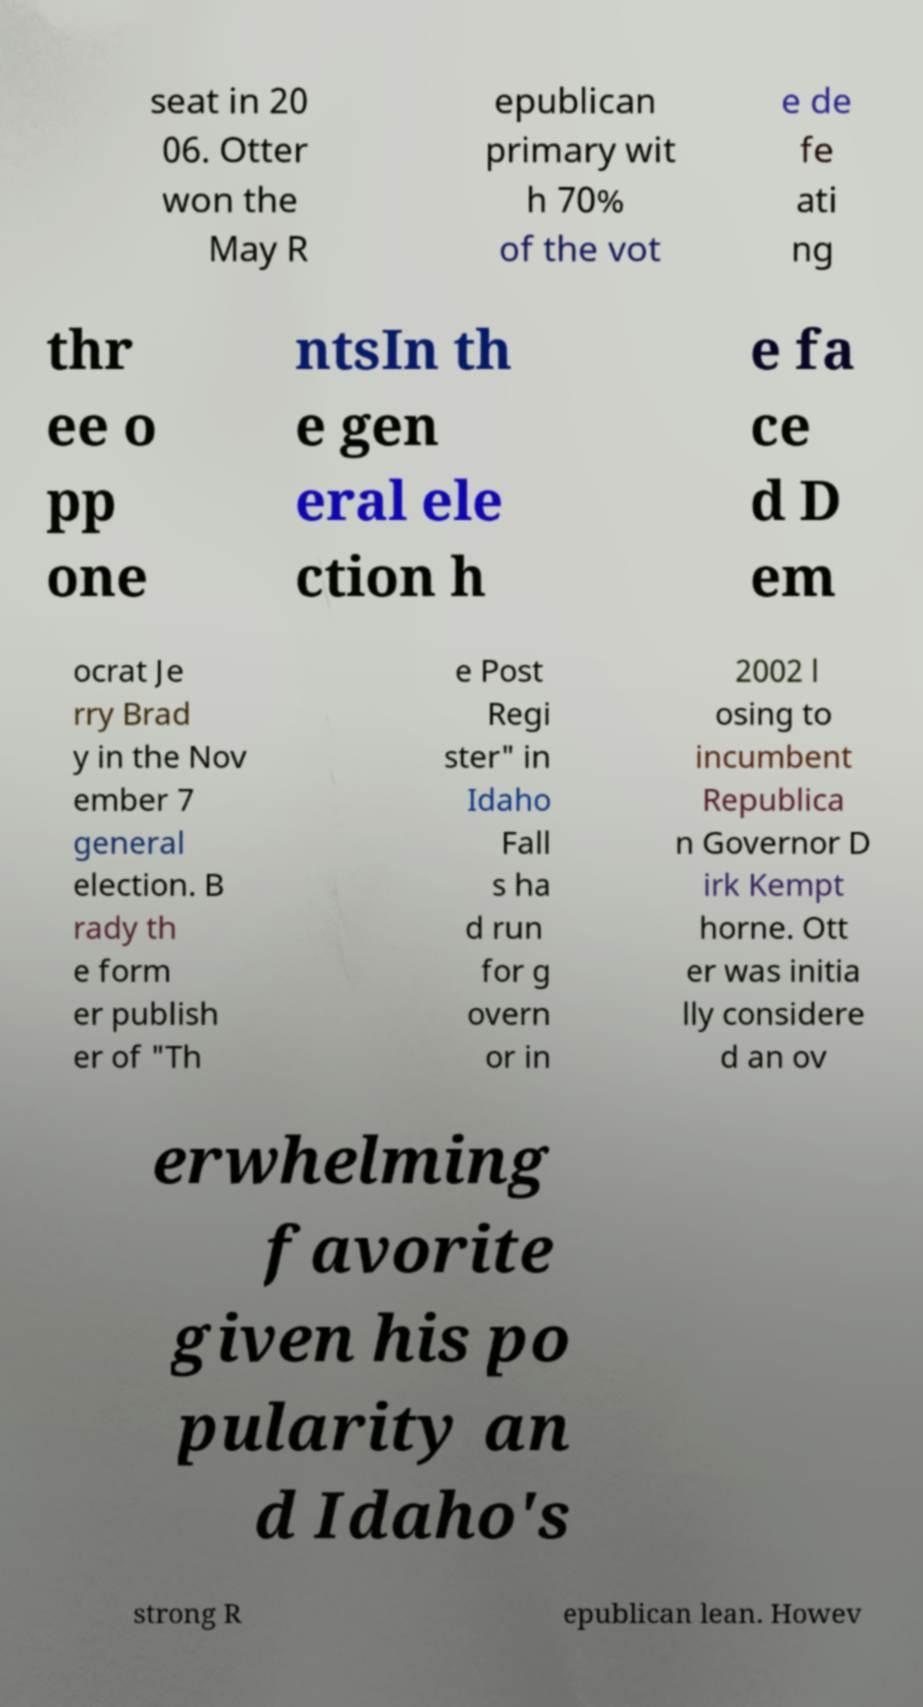Can you read and provide the text displayed in the image?This photo seems to have some interesting text. Can you extract and type it out for me? seat in 20 06. Otter won the May R epublican primary wit h 70% of the vot e de fe ati ng thr ee o pp one ntsIn th e gen eral ele ction h e fa ce d D em ocrat Je rry Brad y in the Nov ember 7 general election. B rady th e form er publish er of "Th e Post Regi ster" in Idaho Fall s ha d run for g overn or in 2002 l osing to incumbent Republica n Governor D irk Kempt horne. Ott er was initia lly considere d an ov erwhelming favorite given his po pularity an d Idaho's strong R epublican lean. Howev 